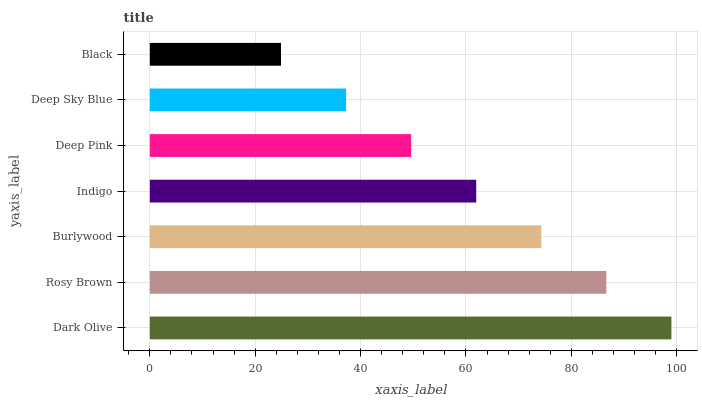Is Black the minimum?
Answer yes or no. Yes. Is Dark Olive the maximum?
Answer yes or no. Yes. Is Rosy Brown the minimum?
Answer yes or no. No. Is Rosy Brown the maximum?
Answer yes or no. No. Is Dark Olive greater than Rosy Brown?
Answer yes or no. Yes. Is Rosy Brown less than Dark Olive?
Answer yes or no. Yes. Is Rosy Brown greater than Dark Olive?
Answer yes or no. No. Is Dark Olive less than Rosy Brown?
Answer yes or no. No. Is Indigo the high median?
Answer yes or no. Yes. Is Indigo the low median?
Answer yes or no. Yes. Is Burlywood the high median?
Answer yes or no. No. Is Rosy Brown the low median?
Answer yes or no. No. 